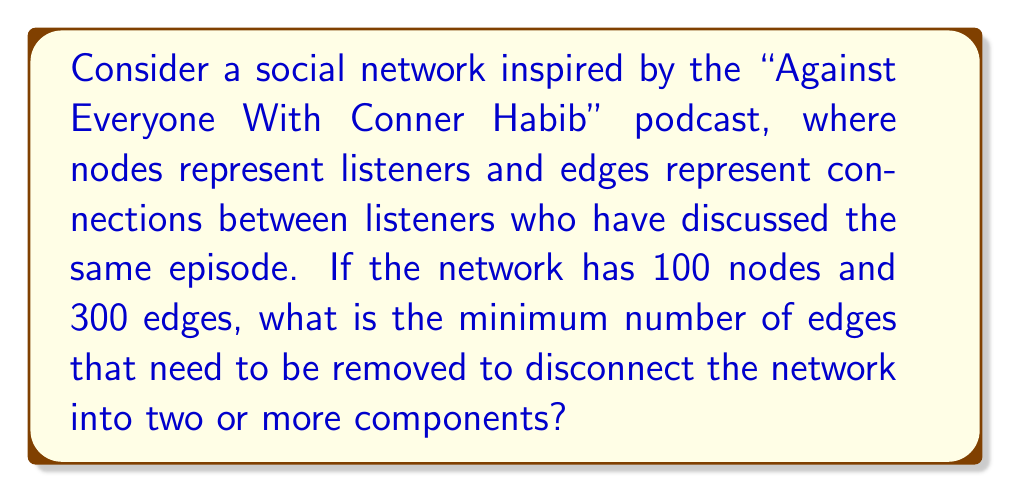Show me your answer to this math problem. To solve this problem, we need to understand the concept of connectedness in graph theory and how it relates to social networks.

1. First, let's consider what it means for a network to be connected:
   - A network is connected if there exists a path between any two nodes.
   - In terms of the podcast network, this means any listener can reach any other listener through a series of connections.

2. The minimum number of edges that need to be removed to disconnect the network is known as the edge connectivity of the graph.

3. For a connected graph with $n$ nodes, the minimum number of edges required to keep it connected is $n-1$. This forms a spanning tree of the graph.

4. In our case:
   - Number of nodes, $n = 100$
   - Number of edges, $e = 300$

5. The number of edges that can be removed while keeping the graph connected is:
   $e - (n-1) = 300 - (100-1) = 300 - 99 = 201$

6. Therefore, the 201st edge removal would disconnect the graph.

7. The edge connectivity of the graph is thus the number of edges that need to be removed plus one:
   $201 + 1 = 202$

This means that removing any 202 edges will guarantee that the network becomes disconnected, regardless of which edges are chosen.

In the context of the podcast network, this represents the resilience of the community. It would take at least 202 broken connections between listeners to fragment the community into isolated groups.
Answer: The minimum number of edges that need to be removed to disconnect the network is 202. 